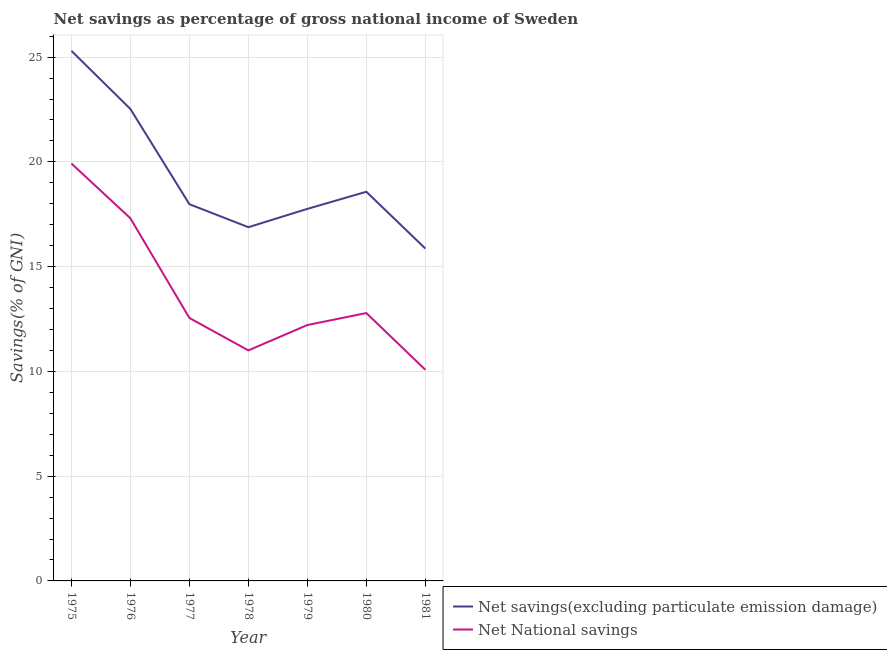Is the number of lines equal to the number of legend labels?
Offer a very short reply. Yes. What is the net savings(excluding particulate emission damage) in 1981?
Make the answer very short. 15.87. Across all years, what is the maximum net savings(excluding particulate emission damage)?
Keep it short and to the point. 25.3. Across all years, what is the minimum net national savings?
Make the answer very short. 10.08. In which year was the net savings(excluding particulate emission damage) maximum?
Your answer should be very brief. 1975. What is the total net national savings in the graph?
Your answer should be very brief. 95.86. What is the difference between the net savings(excluding particulate emission damage) in 1979 and that in 1981?
Make the answer very short. 1.89. What is the difference between the net national savings in 1975 and the net savings(excluding particulate emission damage) in 1977?
Your answer should be compact. 1.94. What is the average net national savings per year?
Offer a terse response. 13.69. In the year 1976, what is the difference between the net national savings and net savings(excluding particulate emission damage)?
Your response must be concise. -5.22. In how many years, is the net national savings greater than 9 %?
Your response must be concise. 7. What is the ratio of the net national savings in 1975 to that in 1980?
Your answer should be compact. 1.56. Is the net savings(excluding particulate emission damage) in 1975 less than that in 1979?
Your answer should be very brief. No. What is the difference between the highest and the second highest net national savings?
Give a very brief answer. 2.61. What is the difference between the highest and the lowest net savings(excluding particulate emission damage)?
Your response must be concise. 9.44. In how many years, is the net national savings greater than the average net national savings taken over all years?
Offer a terse response. 2. Does the net savings(excluding particulate emission damage) monotonically increase over the years?
Provide a succinct answer. No. Is the net savings(excluding particulate emission damage) strictly greater than the net national savings over the years?
Provide a short and direct response. Yes. Is the net national savings strictly less than the net savings(excluding particulate emission damage) over the years?
Your response must be concise. Yes. What is the difference between two consecutive major ticks on the Y-axis?
Make the answer very short. 5. How are the legend labels stacked?
Provide a short and direct response. Vertical. What is the title of the graph?
Offer a very short reply. Net savings as percentage of gross national income of Sweden. Does "Young" appear as one of the legend labels in the graph?
Your response must be concise. No. What is the label or title of the Y-axis?
Your answer should be compact. Savings(% of GNI). What is the Savings(% of GNI) of Net savings(excluding particulate emission damage) in 1975?
Provide a succinct answer. 25.3. What is the Savings(% of GNI) in Net National savings in 1975?
Keep it short and to the point. 19.92. What is the Savings(% of GNI) in Net savings(excluding particulate emission damage) in 1976?
Offer a terse response. 22.52. What is the Savings(% of GNI) of Net National savings in 1976?
Your response must be concise. 17.31. What is the Savings(% of GNI) of Net savings(excluding particulate emission damage) in 1977?
Your answer should be compact. 17.98. What is the Savings(% of GNI) of Net National savings in 1977?
Offer a terse response. 12.55. What is the Savings(% of GNI) of Net savings(excluding particulate emission damage) in 1978?
Your answer should be very brief. 16.88. What is the Savings(% of GNI) in Net National savings in 1978?
Provide a short and direct response. 11. What is the Savings(% of GNI) in Net savings(excluding particulate emission damage) in 1979?
Your answer should be very brief. 17.76. What is the Savings(% of GNI) in Net National savings in 1979?
Offer a terse response. 12.21. What is the Savings(% of GNI) in Net savings(excluding particulate emission damage) in 1980?
Ensure brevity in your answer.  18.57. What is the Savings(% of GNI) of Net National savings in 1980?
Ensure brevity in your answer.  12.79. What is the Savings(% of GNI) in Net savings(excluding particulate emission damage) in 1981?
Offer a very short reply. 15.87. What is the Savings(% of GNI) of Net National savings in 1981?
Keep it short and to the point. 10.08. Across all years, what is the maximum Savings(% of GNI) of Net savings(excluding particulate emission damage)?
Provide a short and direct response. 25.3. Across all years, what is the maximum Savings(% of GNI) in Net National savings?
Make the answer very short. 19.92. Across all years, what is the minimum Savings(% of GNI) in Net savings(excluding particulate emission damage)?
Ensure brevity in your answer.  15.87. Across all years, what is the minimum Savings(% of GNI) of Net National savings?
Provide a short and direct response. 10.08. What is the total Savings(% of GNI) of Net savings(excluding particulate emission damage) in the graph?
Give a very brief answer. 134.89. What is the total Savings(% of GNI) in Net National savings in the graph?
Provide a succinct answer. 95.86. What is the difference between the Savings(% of GNI) of Net savings(excluding particulate emission damage) in 1975 and that in 1976?
Give a very brief answer. 2.78. What is the difference between the Savings(% of GNI) in Net National savings in 1975 and that in 1976?
Your answer should be compact. 2.61. What is the difference between the Savings(% of GNI) in Net savings(excluding particulate emission damage) in 1975 and that in 1977?
Offer a terse response. 7.32. What is the difference between the Savings(% of GNI) in Net National savings in 1975 and that in 1977?
Provide a succinct answer. 7.37. What is the difference between the Savings(% of GNI) of Net savings(excluding particulate emission damage) in 1975 and that in 1978?
Provide a succinct answer. 8.42. What is the difference between the Savings(% of GNI) in Net National savings in 1975 and that in 1978?
Your answer should be very brief. 8.92. What is the difference between the Savings(% of GNI) of Net savings(excluding particulate emission damage) in 1975 and that in 1979?
Your response must be concise. 7.54. What is the difference between the Savings(% of GNI) of Net National savings in 1975 and that in 1979?
Keep it short and to the point. 7.71. What is the difference between the Savings(% of GNI) in Net savings(excluding particulate emission damage) in 1975 and that in 1980?
Your response must be concise. 6.73. What is the difference between the Savings(% of GNI) in Net National savings in 1975 and that in 1980?
Your answer should be compact. 7.14. What is the difference between the Savings(% of GNI) in Net savings(excluding particulate emission damage) in 1975 and that in 1981?
Provide a short and direct response. 9.44. What is the difference between the Savings(% of GNI) in Net National savings in 1975 and that in 1981?
Provide a short and direct response. 9.84. What is the difference between the Savings(% of GNI) of Net savings(excluding particulate emission damage) in 1976 and that in 1977?
Your response must be concise. 4.54. What is the difference between the Savings(% of GNI) in Net National savings in 1976 and that in 1977?
Your response must be concise. 4.76. What is the difference between the Savings(% of GNI) of Net savings(excluding particulate emission damage) in 1976 and that in 1978?
Keep it short and to the point. 5.64. What is the difference between the Savings(% of GNI) of Net National savings in 1976 and that in 1978?
Keep it short and to the point. 6.31. What is the difference between the Savings(% of GNI) in Net savings(excluding particulate emission damage) in 1976 and that in 1979?
Provide a succinct answer. 4.77. What is the difference between the Savings(% of GNI) in Net National savings in 1976 and that in 1979?
Ensure brevity in your answer.  5.1. What is the difference between the Savings(% of GNI) in Net savings(excluding particulate emission damage) in 1976 and that in 1980?
Keep it short and to the point. 3.95. What is the difference between the Savings(% of GNI) in Net National savings in 1976 and that in 1980?
Provide a succinct answer. 4.52. What is the difference between the Savings(% of GNI) in Net savings(excluding particulate emission damage) in 1976 and that in 1981?
Your answer should be very brief. 6.66. What is the difference between the Savings(% of GNI) of Net National savings in 1976 and that in 1981?
Provide a short and direct response. 7.23. What is the difference between the Savings(% of GNI) of Net savings(excluding particulate emission damage) in 1977 and that in 1978?
Give a very brief answer. 1.1. What is the difference between the Savings(% of GNI) of Net National savings in 1977 and that in 1978?
Your answer should be very brief. 1.55. What is the difference between the Savings(% of GNI) of Net savings(excluding particulate emission damage) in 1977 and that in 1979?
Keep it short and to the point. 0.22. What is the difference between the Savings(% of GNI) in Net National savings in 1977 and that in 1979?
Make the answer very short. 0.34. What is the difference between the Savings(% of GNI) of Net savings(excluding particulate emission damage) in 1977 and that in 1980?
Keep it short and to the point. -0.59. What is the difference between the Savings(% of GNI) in Net National savings in 1977 and that in 1980?
Provide a succinct answer. -0.24. What is the difference between the Savings(% of GNI) in Net savings(excluding particulate emission damage) in 1977 and that in 1981?
Your answer should be compact. 2.12. What is the difference between the Savings(% of GNI) in Net National savings in 1977 and that in 1981?
Your response must be concise. 2.47. What is the difference between the Savings(% of GNI) of Net savings(excluding particulate emission damage) in 1978 and that in 1979?
Provide a short and direct response. -0.87. What is the difference between the Savings(% of GNI) of Net National savings in 1978 and that in 1979?
Provide a short and direct response. -1.21. What is the difference between the Savings(% of GNI) in Net savings(excluding particulate emission damage) in 1978 and that in 1980?
Your response must be concise. -1.69. What is the difference between the Savings(% of GNI) of Net National savings in 1978 and that in 1980?
Offer a terse response. -1.78. What is the difference between the Savings(% of GNI) of Net savings(excluding particulate emission damage) in 1978 and that in 1981?
Your answer should be compact. 1.02. What is the difference between the Savings(% of GNI) in Net National savings in 1978 and that in 1981?
Offer a terse response. 0.92. What is the difference between the Savings(% of GNI) in Net savings(excluding particulate emission damage) in 1979 and that in 1980?
Offer a very short reply. -0.82. What is the difference between the Savings(% of GNI) of Net National savings in 1979 and that in 1980?
Ensure brevity in your answer.  -0.57. What is the difference between the Savings(% of GNI) of Net savings(excluding particulate emission damage) in 1979 and that in 1981?
Provide a short and direct response. 1.89. What is the difference between the Savings(% of GNI) of Net National savings in 1979 and that in 1981?
Your answer should be compact. 2.13. What is the difference between the Savings(% of GNI) in Net savings(excluding particulate emission damage) in 1980 and that in 1981?
Offer a terse response. 2.71. What is the difference between the Savings(% of GNI) of Net National savings in 1980 and that in 1981?
Offer a very short reply. 2.71. What is the difference between the Savings(% of GNI) in Net savings(excluding particulate emission damage) in 1975 and the Savings(% of GNI) in Net National savings in 1976?
Make the answer very short. 7.99. What is the difference between the Savings(% of GNI) in Net savings(excluding particulate emission damage) in 1975 and the Savings(% of GNI) in Net National savings in 1977?
Your answer should be very brief. 12.75. What is the difference between the Savings(% of GNI) in Net savings(excluding particulate emission damage) in 1975 and the Savings(% of GNI) in Net National savings in 1978?
Offer a very short reply. 14.3. What is the difference between the Savings(% of GNI) of Net savings(excluding particulate emission damage) in 1975 and the Savings(% of GNI) of Net National savings in 1979?
Give a very brief answer. 13.09. What is the difference between the Savings(% of GNI) of Net savings(excluding particulate emission damage) in 1975 and the Savings(% of GNI) of Net National savings in 1980?
Offer a terse response. 12.52. What is the difference between the Savings(% of GNI) in Net savings(excluding particulate emission damage) in 1975 and the Savings(% of GNI) in Net National savings in 1981?
Your response must be concise. 15.22. What is the difference between the Savings(% of GNI) in Net savings(excluding particulate emission damage) in 1976 and the Savings(% of GNI) in Net National savings in 1977?
Offer a terse response. 9.97. What is the difference between the Savings(% of GNI) of Net savings(excluding particulate emission damage) in 1976 and the Savings(% of GNI) of Net National savings in 1978?
Your answer should be compact. 11.52. What is the difference between the Savings(% of GNI) of Net savings(excluding particulate emission damage) in 1976 and the Savings(% of GNI) of Net National savings in 1979?
Keep it short and to the point. 10.31. What is the difference between the Savings(% of GNI) in Net savings(excluding particulate emission damage) in 1976 and the Savings(% of GNI) in Net National savings in 1980?
Keep it short and to the point. 9.74. What is the difference between the Savings(% of GNI) in Net savings(excluding particulate emission damage) in 1976 and the Savings(% of GNI) in Net National savings in 1981?
Provide a succinct answer. 12.45. What is the difference between the Savings(% of GNI) of Net savings(excluding particulate emission damage) in 1977 and the Savings(% of GNI) of Net National savings in 1978?
Keep it short and to the point. 6.98. What is the difference between the Savings(% of GNI) in Net savings(excluding particulate emission damage) in 1977 and the Savings(% of GNI) in Net National savings in 1979?
Provide a short and direct response. 5.77. What is the difference between the Savings(% of GNI) in Net savings(excluding particulate emission damage) in 1977 and the Savings(% of GNI) in Net National savings in 1980?
Provide a short and direct response. 5.2. What is the difference between the Savings(% of GNI) of Net savings(excluding particulate emission damage) in 1977 and the Savings(% of GNI) of Net National savings in 1981?
Provide a short and direct response. 7.9. What is the difference between the Savings(% of GNI) of Net savings(excluding particulate emission damage) in 1978 and the Savings(% of GNI) of Net National savings in 1979?
Ensure brevity in your answer.  4.67. What is the difference between the Savings(% of GNI) of Net savings(excluding particulate emission damage) in 1978 and the Savings(% of GNI) of Net National savings in 1980?
Provide a short and direct response. 4.1. What is the difference between the Savings(% of GNI) of Net savings(excluding particulate emission damage) in 1978 and the Savings(% of GNI) of Net National savings in 1981?
Make the answer very short. 6.8. What is the difference between the Savings(% of GNI) in Net savings(excluding particulate emission damage) in 1979 and the Savings(% of GNI) in Net National savings in 1980?
Give a very brief answer. 4.97. What is the difference between the Savings(% of GNI) in Net savings(excluding particulate emission damage) in 1979 and the Savings(% of GNI) in Net National savings in 1981?
Your response must be concise. 7.68. What is the difference between the Savings(% of GNI) of Net savings(excluding particulate emission damage) in 1980 and the Savings(% of GNI) of Net National savings in 1981?
Keep it short and to the point. 8.5. What is the average Savings(% of GNI) in Net savings(excluding particulate emission damage) per year?
Your response must be concise. 19.27. What is the average Savings(% of GNI) in Net National savings per year?
Give a very brief answer. 13.69. In the year 1975, what is the difference between the Savings(% of GNI) of Net savings(excluding particulate emission damage) and Savings(% of GNI) of Net National savings?
Make the answer very short. 5.38. In the year 1976, what is the difference between the Savings(% of GNI) in Net savings(excluding particulate emission damage) and Savings(% of GNI) in Net National savings?
Ensure brevity in your answer.  5.22. In the year 1977, what is the difference between the Savings(% of GNI) in Net savings(excluding particulate emission damage) and Savings(% of GNI) in Net National savings?
Offer a very short reply. 5.43. In the year 1978, what is the difference between the Savings(% of GNI) in Net savings(excluding particulate emission damage) and Savings(% of GNI) in Net National savings?
Provide a succinct answer. 5.88. In the year 1979, what is the difference between the Savings(% of GNI) in Net savings(excluding particulate emission damage) and Savings(% of GNI) in Net National savings?
Offer a very short reply. 5.54. In the year 1980, what is the difference between the Savings(% of GNI) of Net savings(excluding particulate emission damage) and Savings(% of GNI) of Net National savings?
Your response must be concise. 5.79. In the year 1981, what is the difference between the Savings(% of GNI) of Net savings(excluding particulate emission damage) and Savings(% of GNI) of Net National savings?
Ensure brevity in your answer.  5.79. What is the ratio of the Savings(% of GNI) of Net savings(excluding particulate emission damage) in 1975 to that in 1976?
Offer a terse response. 1.12. What is the ratio of the Savings(% of GNI) of Net National savings in 1975 to that in 1976?
Keep it short and to the point. 1.15. What is the ratio of the Savings(% of GNI) in Net savings(excluding particulate emission damage) in 1975 to that in 1977?
Keep it short and to the point. 1.41. What is the ratio of the Savings(% of GNI) in Net National savings in 1975 to that in 1977?
Provide a succinct answer. 1.59. What is the ratio of the Savings(% of GNI) of Net savings(excluding particulate emission damage) in 1975 to that in 1978?
Your answer should be compact. 1.5. What is the ratio of the Savings(% of GNI) in Net National savings in 1975 to that in 1978?
Your response must be concise. 1.81. What is the ratio of the Savings(% of GNI) in Net savings(excluding particulate emission damage) in 1975 to that in 1979?
Ensure brevity in your answer.  1.42. What is the ratio of the Savings(% of GNI) of Net National savings in 1975 to that in 1979?
Your answer should be very brief. 1.63. What is the ratio of the Savings(% of GNI) in Net savings(excluding particulate emission damage) in 1975 to that in 1980?
Offer a very short reply. 1.36. What is the ratio of the Savings(% of GNI) in Net National savings in 1975 to that in 1980?
Make the answer very short. 1.56. What is the ratio of the Savings(% of GNI) in Net savings(excluding particulate emission damage) in 1975 to that in 1981?
Ensure brevity in your answer.  1.59. What is the ratio of the Savings(% of GNI) in Net National savings in 1975 to that in 1981?
Offer a terse response. 1.98. What is the ratio of the Savings(% of GNI) in Net savings(excluding particulate emission damage) in 1976 to that in 1977?
Keep it short and to the point. 1.25. What is the ratio of the Savings(% of GNI) in Net National savings in 1976 to that in 1977?
Offer a very short reply. 1.38. What is the ratio of the Savings(% of GNI) of Net savings(excluding particulate emission damage) in 1976 to that in 1978?
Make the answer very short. 1.33. What is the ratio of the Savings(% of GNI) of Net National savings in 1976 to that in 1978?
Make the answer very short. 1.57. What is the ratio of the Savings(% of GNI) in Net savings(excluding particulate emission damage) in 1976 to that in 1979?
Make the answer very short. 1.27. What is the ratio of the Savings(% of GNI) in Net National savings in 1976 to that in 1979?
Your answer should be compact. 1.42. What is the ratio of the Savings(% of GNI) of Net savings(excluding particulate emission damage) in 1976 to that in 1980?
Your response must be concise. 1.21. What is the ratio of the Savings(% of GNI) of Net National savings in 1976 to that in 1980?
Give a very brief answer. 1.35. What is the ratio of the Savings(% of GNI) of Net savings(excluding particulate emission damage) in 1976 to that in 1981?
Offer a very short reply. 1.42. What is the ratio of the Savings(% of GNI) of Net National savings in 1976 to that in 1981?
Make the answer very short. 1.72. What is the ratio of the Savings(% of GNI) of Net savings(excluding particulate emission damage) in 1977 to that in 1978?
Keep it short and to the point. 1.06. What is the ratio of the Savings(% of GNI) in Net National savings in 1977 to that in 1978?
Your answer should be very brief. 1.14. What is the ratio of the Savings(% of GNI) in Net savings(excluding particulate emission damage) in 1977 to that in 1979?
Offer a terse response. 1.01. What is the ratio of the Savings(% of GNI) in Net National savings in 1977 to that in 1979?
Ensure brevity in your answer.  1.03. What is the ratio of the Savings(% of GNI) in Net savings(excluding particulate emission damage) in 1977 to that in 1980?
Give a very brief answer. 0.97. What is the ratio of the Savings(% of GNI) of Net National savings in 1977 to that in 1980?
Provide a short and direct response. 0.98. What is the ratio of the Savings(% of GNI) in Net savings(excluding particulate emission damage) in 1977 to that in 1981?
Make the answer very short. 1.13. What is the ratio of the Savings(% of GNI) of Net National savings in 1977 to that in 1981?
Your answer should be very brief. 1.25. What is the ratio of the Savings(% of GNI) in Net savings(excluding particulate emission damage) in 1978 to that in 1979?
Your answer should be very brief. 0.95. What is the ratio of the Savings(% of GNI) in Net National savings in 1978 to that in 1979?
Offer a very short reply. 0.9. What is the ratio of the Savings(% of GNI) in Net savings(excluding particulate emission damage) in 1978 to that in 1980?
Offer a very short reply. 0.91. What is the ratio of the Savings(% of GNI) of Net National savings in 1978 to that in 1980?
Your answer should be very brief. 0.86. What is the ratio of the Savings(% of GNI) of Net savings(excluding particulate emission damage) in 1978 to that in 1981?
Your answer should be compact. 1.06. What is the ratio of the Savings(% of GNI) of Net National savings in 1978 to that in 1981?
Give a very brief answer. 1.09. What is the ratio of the Savings(% of GNI) of Net savings(excluding particulate emission damage) in 1979 to that in 1980?
Provide a short and direct response. 0.96. What is the ratio of the Savings(% of GNI) in Net National savings in 1979 to that in 1980?
Offer a very short reply. 0.96. What is the ratio of the Savings(% of GNI) in Net savings(excluding particulate emission damage) in 1979 to that in 1981?
Give a very brief answer. 1.12. What is the ratio of the Savings(% of GNI) of Net National savings in 1979 to that in 1981?
Your answer should be very brief. 1.21. What is the ratio of the Savings(% of GNI) in Net savings(excluding particulate emission damage) in 1980 to that in 1981?
Provide a short and direct response. 1.17. What is the ratio of the Savings(% of GNI) of Net National savings in 1980 to that in 1981?
Ensure brevity in your answer.  1.27. What is the difference between the highest and the second highest Savings(% of GNI) of Net savings(excluding particulate emission damage)?
Your answer should be very brief. 2.78. What is the difference between the highest and the second highest Savings(% of GNI) in Net National savings?
Your answer should be very brief. 2.61. What is the difference between the highest and the lowest Savings(% of GNI) in Net savings(excluding particulate emission damage)?
Your answer should be very brief. 9.44. What is the difference between the highest and the lowest Savings(% of GNI) in Net National savings?
Make the answer very short. 9.84. 